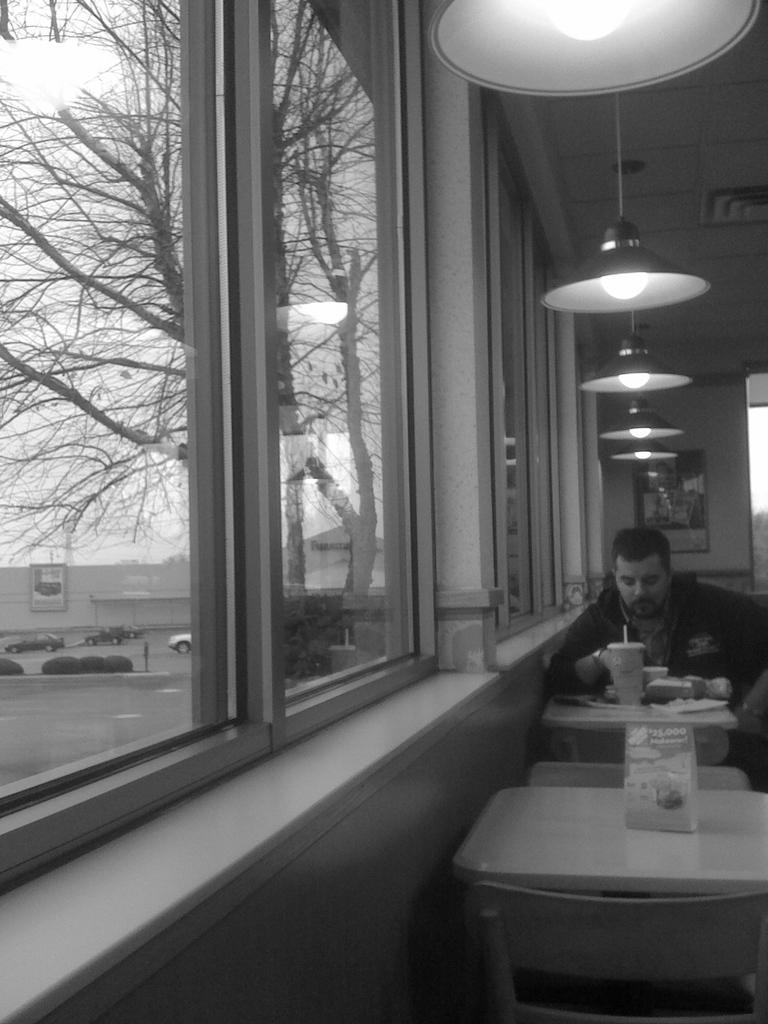What is the person in the image doing? The person is sitting on the table and having food. What can be seen on the left side of the image? There are windows, cars, and trees on the left side of the image. Are there any lights visible in the image? Yes, there are lights visible at the top of the image. What type of blade is being used by the person to cut the food in the image? There is no blade visible in the image; the person is likely using a utensil like a fork or spoon to eat the food. 